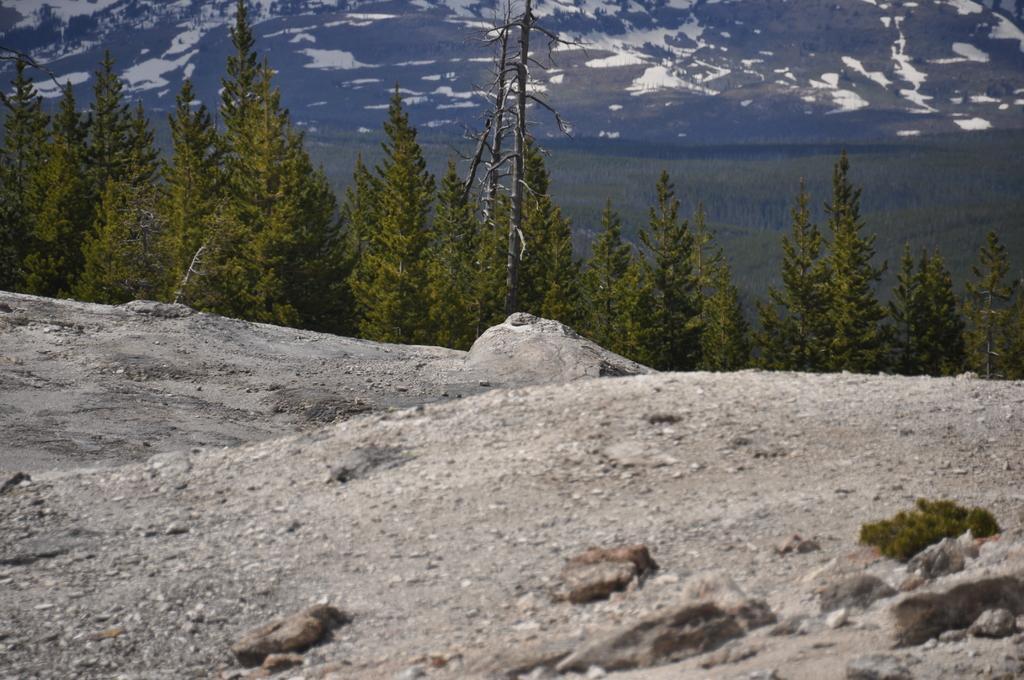In one or two sentences, can you explain what this image depicts? At the bottom, we see the stones and the rock surface. In the middle, we see trees. There are trees and the hills in the background. 